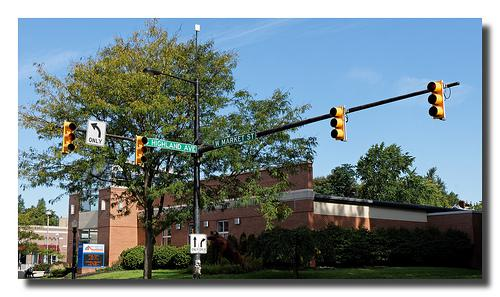Question: how busy does this intersection look?
Choices:
A. Not busy.
B. Busy.
C. Closed.
D. Under construction.
Answer with the letter. Answer: A Question: what is the main street sign color?
Choices:
A. Red.
B. Yellow.
C. Black.
D. Green.
Answer with the letter. Answer: D Question: what will the sky do in a few hours?
Choices:
A. Become cloudy.
B. Get lighter.
C. Begin to rain.
D. Get dark.
Answer with the letter. Answer: D Question: what plants are in front of the building?
Choices:
A. Ivy.
B. Roses.
C. Boxwood.
D. Bonsai trees.
Answer with the letter. Answer: C 